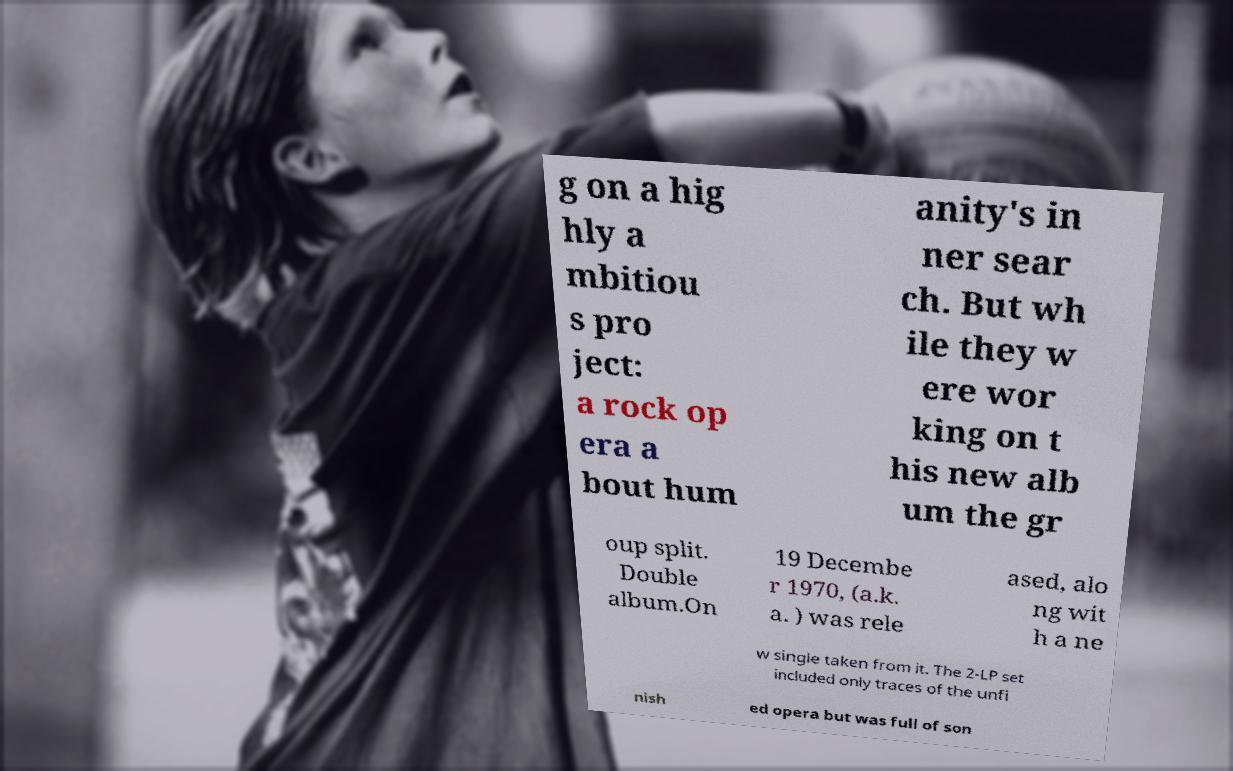Can you accurately transcribe the text from the provided image for me? g on a hig hly a mbitiou s pro ject: a rock op era a bout hum anity's in ner sear ch. But wh ile they w ere wor king on t his new alb um the gr oup split. Double album.On 19 Decembe r 1970, (a.k. a. ) was rele ased, alo ng wit h a ne w single taken from it. The 2-LP set included only traces of the unfi nish ed opera but was full of son 